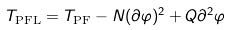Convert formula to latex. <formula><loc_0><loc_0><loc_500><loc_500>T _ { \text {PFL} } = T _ { \text {PF} } - N ( \partial \varphi ) ^ { 2 } + Q \partial ^ { 2 } \varphi</formula> 